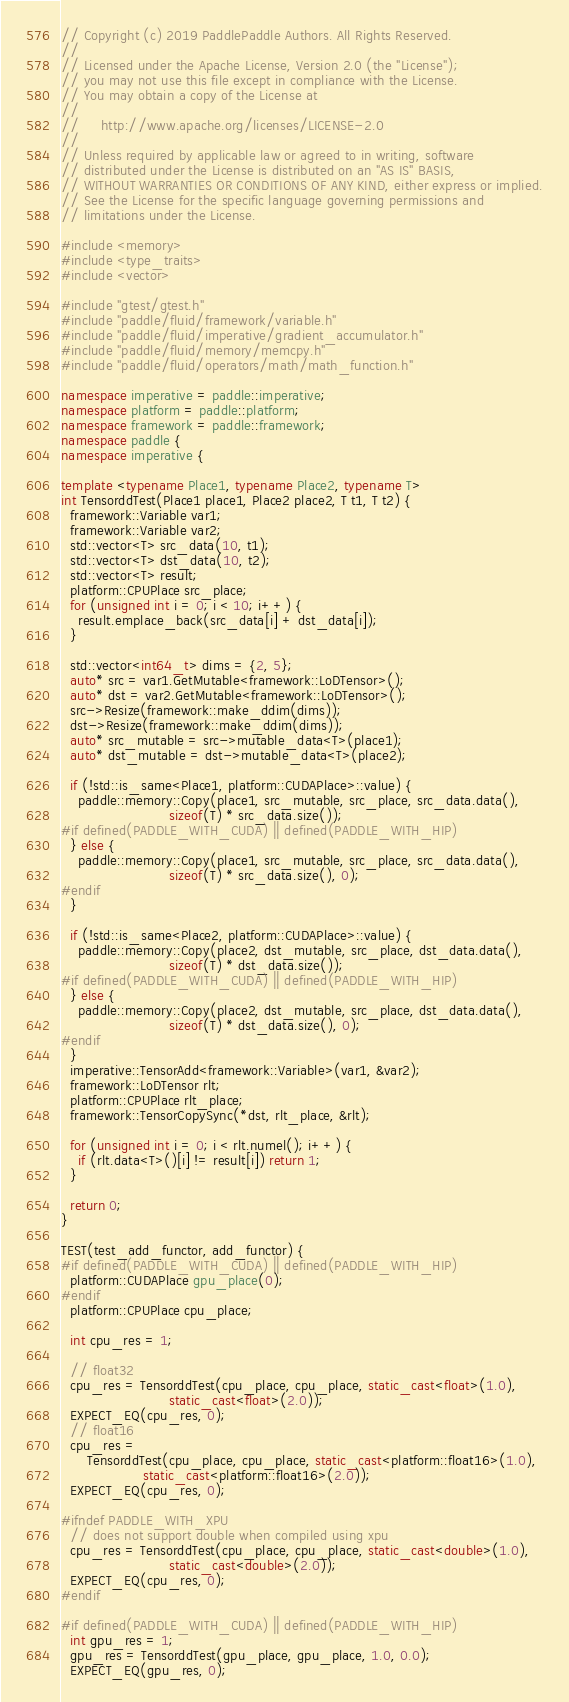<code> <loc_0><loc_0><loc_500><loc_500><_C++_>// Copyright (c) 2019 PaddlePaddle Authors. All Rights Reserved.
//
// Licensed under the Apache License, Version 2.0 (the "License");
// you may not use this file except in compliance with the License.
// You may obtain a copy of the License at
//
//     http://www.apache.org/licenses/LICENSE-2.0
//
// Unless required by applicable law or agreed to in writing, software
// distributed under the License is distributed on an "AS IS" BASIS,
// WITHOUT WARRANTIES OR CONDITIONS OF ANY KIND, either express or implied.
// See the License for the specific language governing permissions and
// limitations under the License.

#include <memory>
#include <type_traits>
#include <vector>

#include "gtest/gtest.h"
#include "paddle/fluid/framework/variable.h"
#include "paddle/fluid/imperative/gradient_accumulator.h"
#include "paddle/fluid/memory/memcpy.h"
#include "paddle/fluid/operators/math/math_function.h"

namespace imperative = paddle::imperative;
namespace platform = paddle::platform;
namespace framework = paddle::framework;
namespace paddle {
namespace imperative {

template <typename Place1, typename Place2, typename T>
int TensorddTest(Place1 place1, Place2 place2, T t1, T t2) {
  framework::Variable var1;
  framework::Variable var2;
  std::vector<T> src_data(10, t1);
  std::vector<T> dst_data(10, t2);
  std::vector<T> result;
  platform::CPUPlace src_place;
  for (unsigned int i = 0; i < 10; i++) {
    result.emplace_back(src_data[i] + dst_data[i]);
  }

  std::vector<int64_t> dims = {2, 5};
  auto* src = var1.GetMutable<framework::LoDTensor>();
  auto* dst = var2.GetMutable<framework::LoDTensor>();
  src->Resize(framework::make_ddim(dims));
  dst->Resize(framework::make_ddim(dims));
  auto* src_mutable = src->mutable_data<T>(place1);
  auto* dst_mutable = dst->mutable_data<T>(place2);

  if (!std::is_same<Place1, platform::CUDAPlace>::value) {
    paddle::memory::Copy(place1, src_mutable, src_place, src_data.data(),
                         sizeof(T) * src_data.size());
#if defined(PADDLE_WITH_CUDA) || defined(PADDLE_WITH_HIP)
  } else {
    paddle::memory::Copy(place1, src_mutable, src_place, src_data.data(),
                         sizeof(T) * src_data.size(), 0);
#endif
  }

  if (!std::is_same<Place2, platform::CUDAPlace>::value) {
    paddle::memory::Copy(place2, dst_mutable, src_place, dst_data.data(),
                         sizeof(T) * dst_data.size());
#if defined(PADDLE_WITH_CUDA) || defined(PADDLE_WITH_HIP)
  } else {
    paddle::memory::Copy(place2, dst_mutable, src_place, dst_data.data(),
                         sizeof(T) * dst_data.size(), 0);
#endif
  }
  imperative::TensorAdd<framework::Variable>(var1, &var2);
  framework::LoDTensor rlt;
  platform::CPUPlace rlt_place;
  framework::TensorCopySync(*dst, rlt_place, &rlt);

  for (unsigned int i = 0; i < rlt.numel(); i++) {
    if (rlt.data<T>()[i] != result[i]) return 1;
  }

  return 0;
}

TEST(test_add_functor, add_functor) {
#if defined(PADDLE_WITH_CUDA) || defined(PADDLE_WITH_HIP)
  platform::CUDAPlace gpu_place(0);
#endif
  platform::CPUPlace cpu_place;

  int cpu_res = 1;

  // float32
  cpu_res = TensorddTest(cpu_place, cpu_place, static_cast<float>(1.0),
                         static_cast<float>(2.0));
  EXPECT_EQ(cpu_res, 0);
  // float16
  cpu_res =
      TensorddTest(cpu_place, cpu_place, static_cast<platform::float16>(1.0),
                   static_cast<platform::float16>(2.0));
  EXPECT_EQ(cpu_res, 0);

#ifndef PADDLE_WITH_XPU
  // does not support double when compiled using xpu
  cpu_res = TensorddTest(cpu_place, cpu_place, static_cast<double>(1.0),
                         static_cast<double>(2.0));
  EXPECT_EQ(cpu_res, 0);
#endif

#if defined(PADDLE_WITH_CUDA) || defined(PADDLE_WITH_HIP)
  int gpu_res = 1;
  gpu_res = TensorddTest(gpu_place, gpu_place, 1.0, 0.0);
  EXPECT_EQ(gpu_res, 0);</code> 